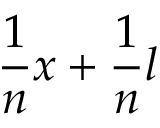<formula> <loc_0><loc_0><loc_500><loc_500>{ \frac { 1 } { n } } x + { \frac { 1 } { n } } l</formula> 